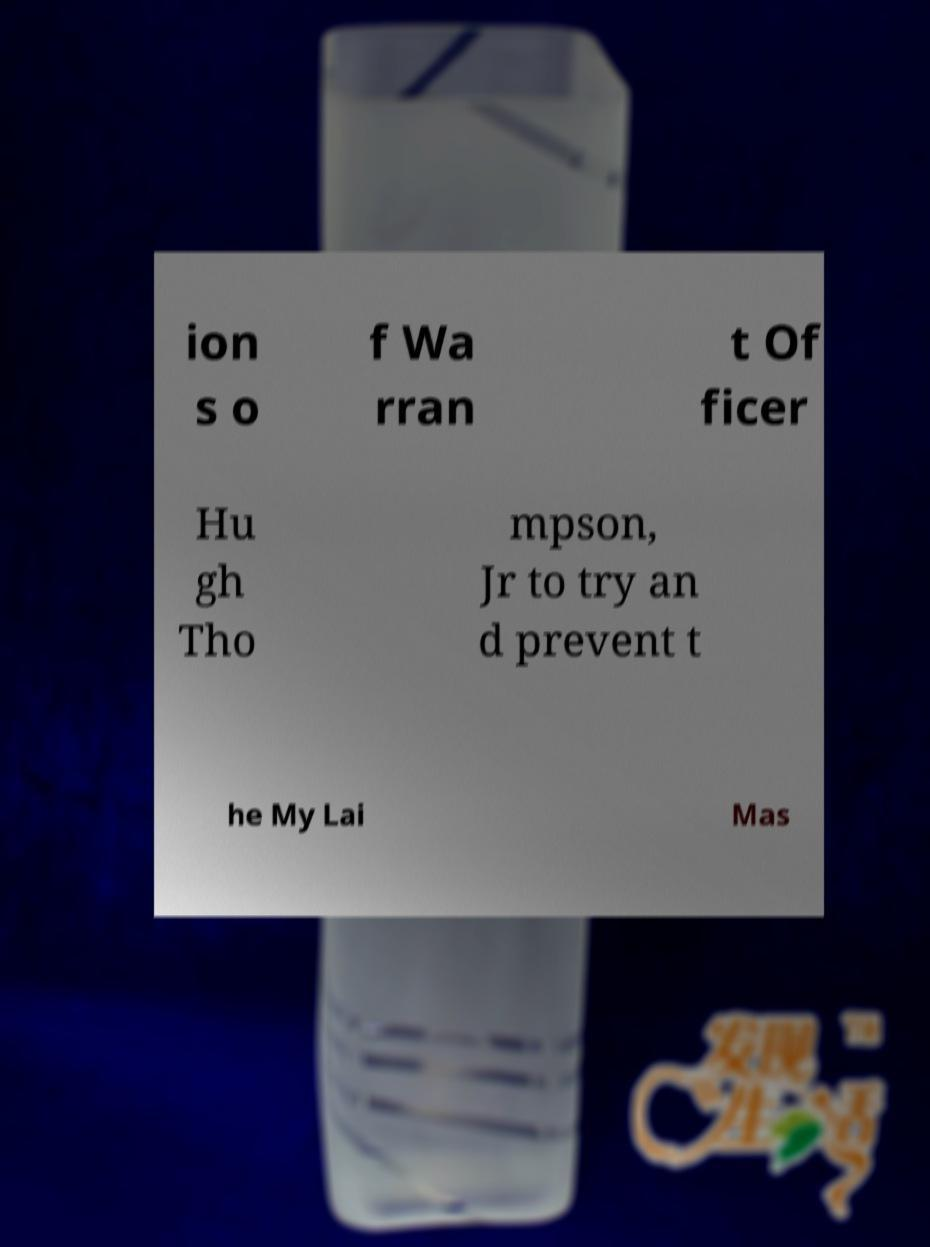There's text embedded in this image that I need extracted. Can you transcribe it verbatim? ion s o f Wa rran t Of ficer Hu gh Tho mpson, Jr to try an d prevent t he My Lai Mas 